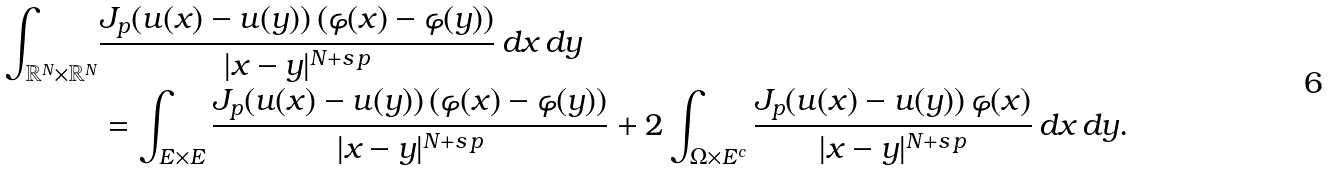<formula> <loc_0><loc_0><loc_500><loc_500>\int _ { \mathbb { R } ^ { N } \times \mathbb { R } ^ { N } } & \frac { J _ { p } ( u ( x ) - u ( y ) ) \, ( \varphi ( x ) - \varphi ( y ) ) } { | x - y | ^ { N + s \, p } } \, d x \, d y \\ & = \int _ { E \times E } \frac { J _ { p } ( u ( x ) - u ( y ) ) \, ( \varphi ( x ) - \varphi ( y ) ) } { | x - y | ^ { N + s \, p } } + 2 \int _ { \Omega \times E ^ { c } } \frac { J _ { p } ( u ( x ) - u ( y ) ) \, \varphi ( x ) } { | x - y | ^ { N + s \, p } } \, d x \, d y .</formula> 